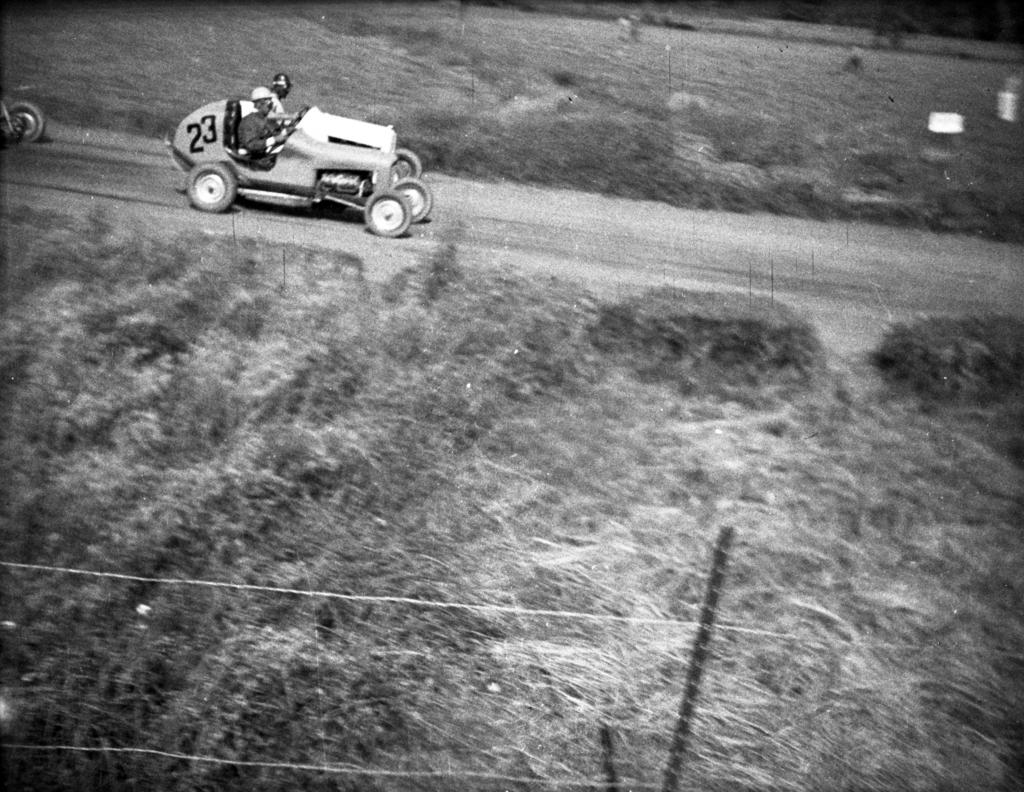What is the main object in the image? There is a pole in the image. What else can be seen in the image besides the pole? There are wires and vehicles in the image. Are there any people in the image? Yes, two persons are sitting in the vehicles. Can you describe any additional details in the image? There are numbers written in the image. What type of square is being judged by the giants in the image? There is no square, judge, or giants present in the image. 